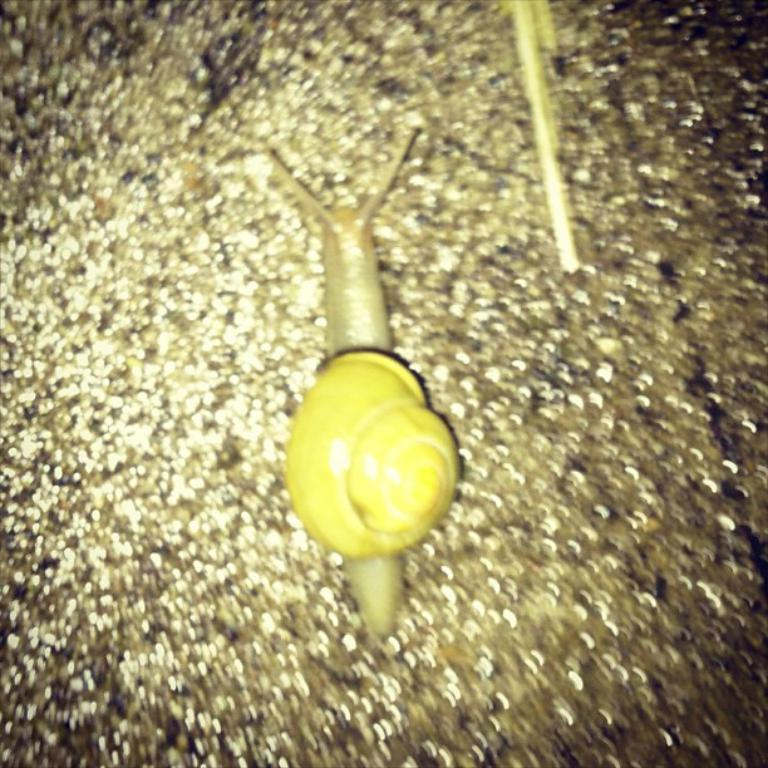What can be seen in the image? There is an object in the image. What type of hobbies does the fowl in the image enjoy? There is no fowl present in the image, so it is not possible to determine what hobbies it might enjoy. 